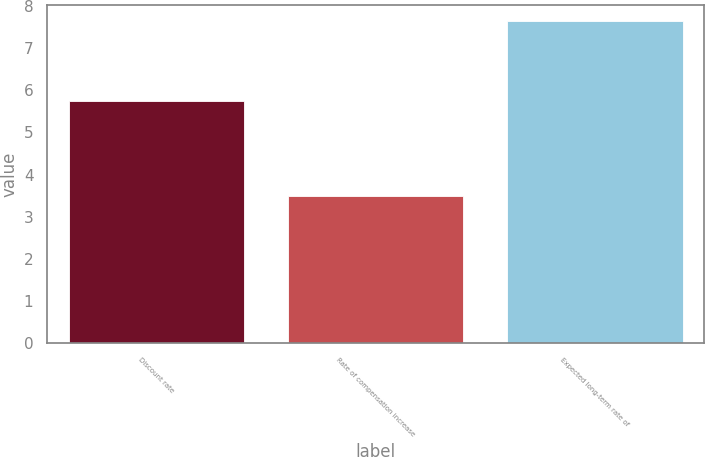Convert chart to OTSL. <chart><loc_0><loc_0><loc_500><loc_500><bar_chart><fcel>Discount rate<fcel>Rate of compensation increase<fcel>Expected long-term rate of<nl><fcel>5.75<fcel>3.5<fcel>7.65<nl></chart> 